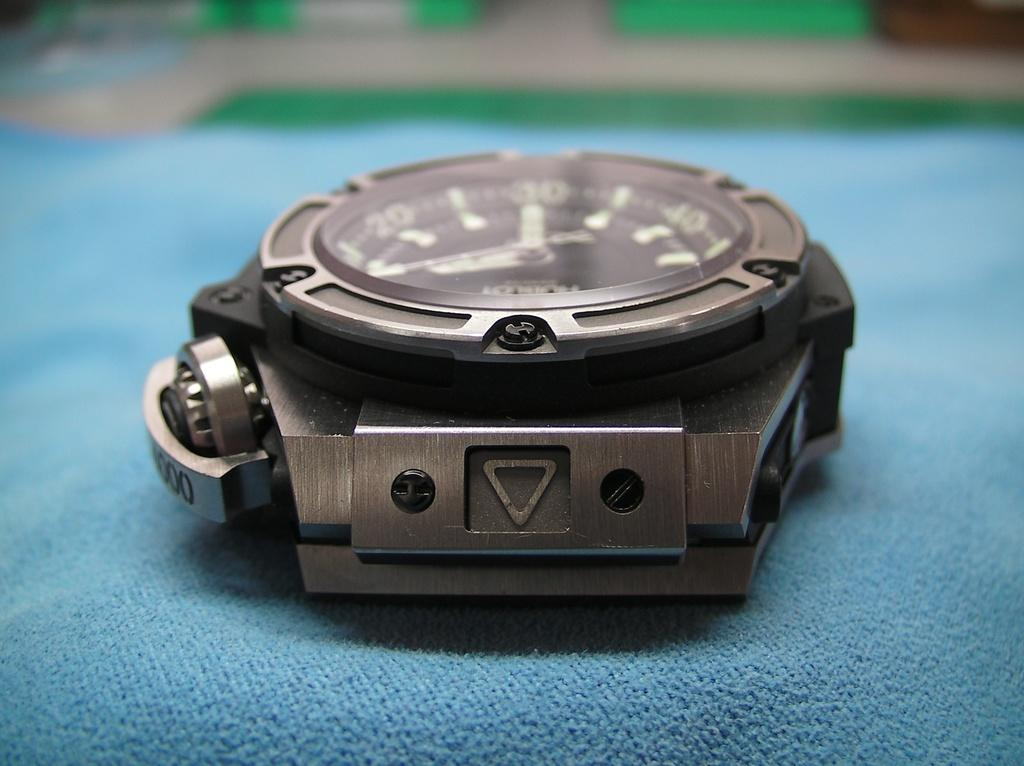<image>
Present a compact description of the photo's key features. Silver metal round watch with the number 30 in green. 